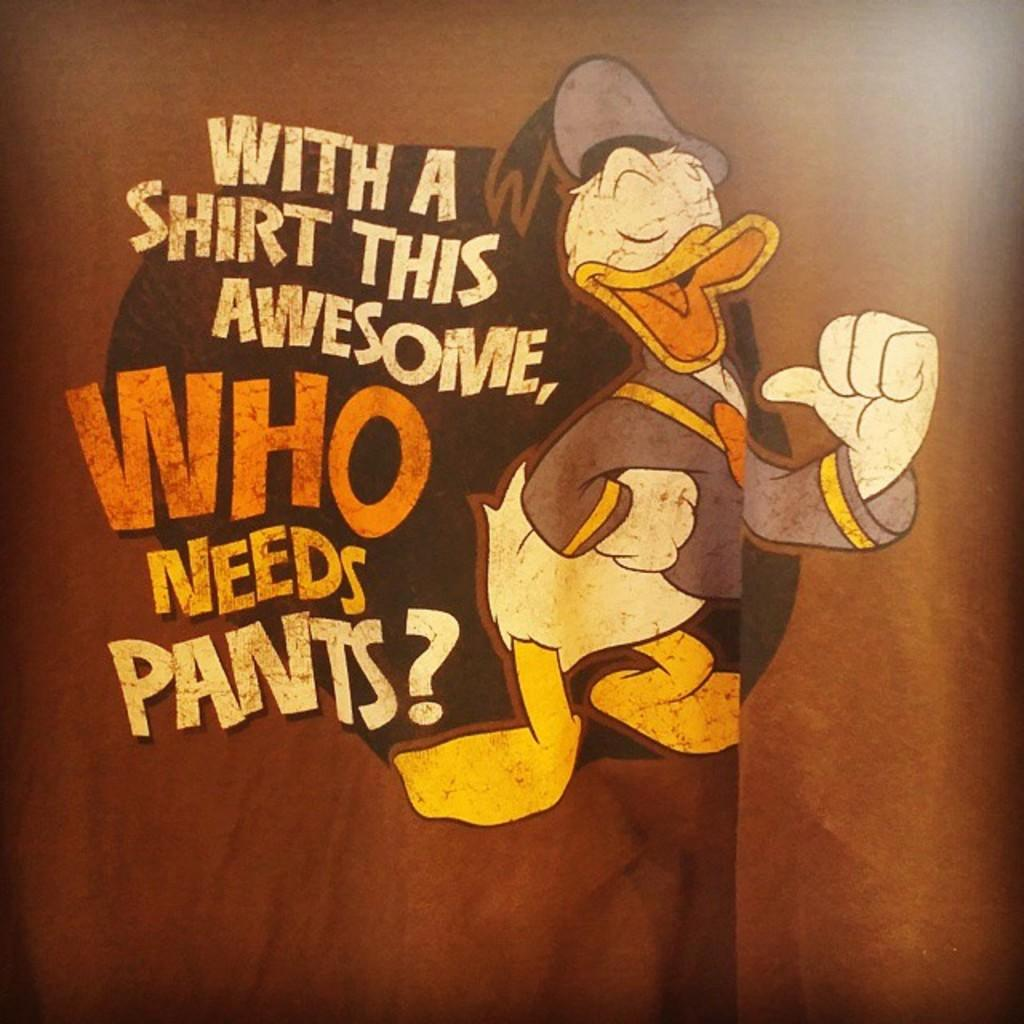What character is present in the image? There is a Donald Duck character in the image. What else can be seen in the image besides the character? There is edited text in the image. What is the color of the background in the image? The background of the image is brown in color. How many pears are visible in the image? There are no pears present in the image. What is the mindset of the goldfish in the image? There is no goldfish present in the image, so it is not possible to determine the mindset of a goldfish. 